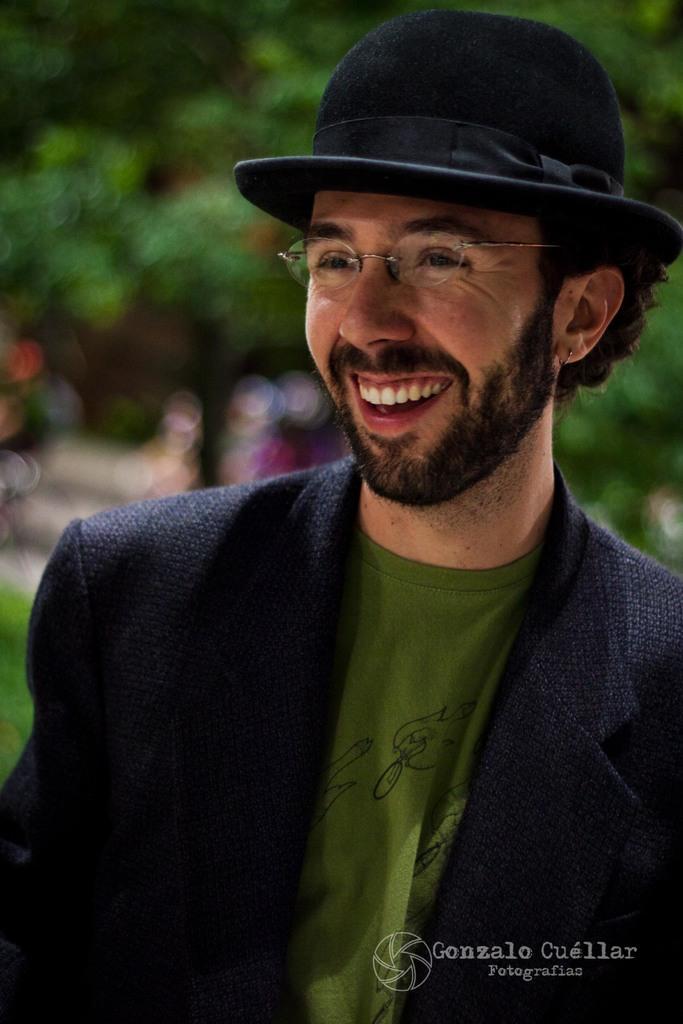Please provide a concise description of this image. In this image there is a person with a smile on his face. The background is blurred. At the bottom of the image there is some text. 